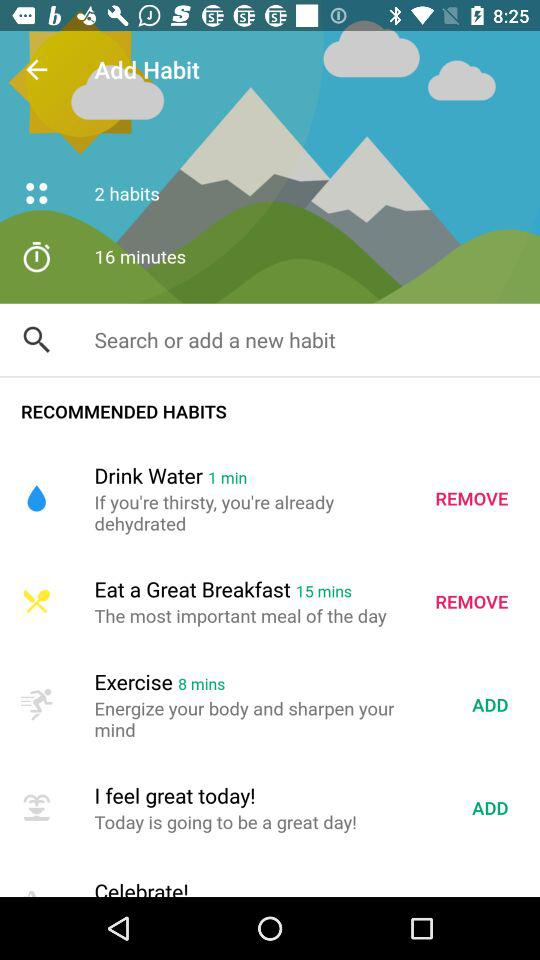What is the time duration for "Eat a Great Breakfast"? The time duration is 15 minutes. 